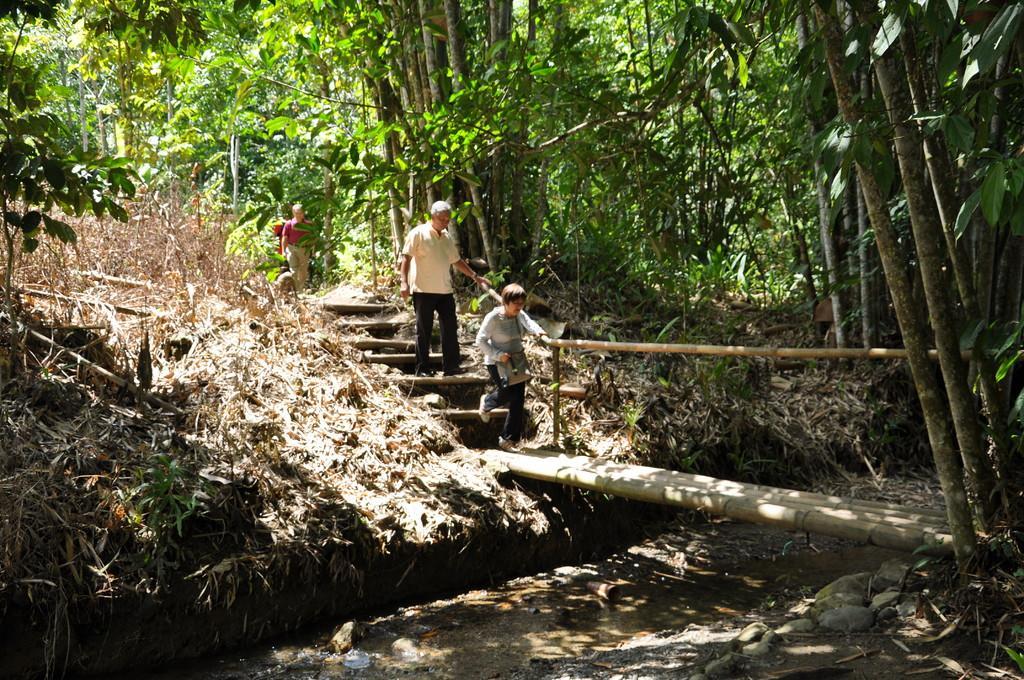Describe this image in one or two sentences. In the center of the image we can see people and there are stairs. At the bottom there is a bridge. In the background there are trees and we can see grass. 